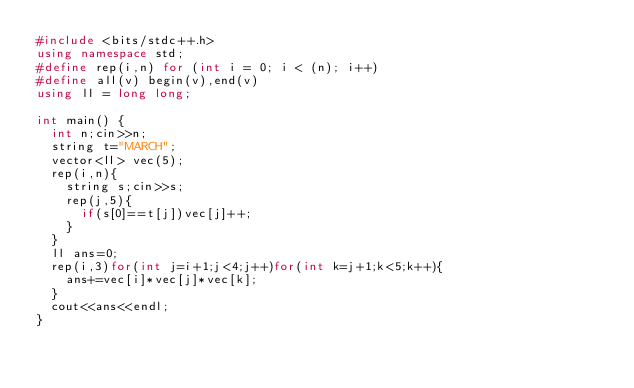Convert code to text. <code><loc_0><loc_0><loc_500><loc_500><_C++_>#include <bits/stdc++.h>
using namespace std;
#define rep(i,n) for (int i = 0; i < (n); i++) 
#define all(v) begin(v),end(v)
using ll = long long;

int main() {
  int n;cin>>n;
  string t="MARCH";
  vector<ll> vec(5);
  rep(i,n){
    string s;cin>>s;
    rep(j,5){
      if(s[0]==t[j])vec[j]++;
    }
  }
  ll ans=0;
  rep(i,3)for(int j=i+1;j<4;j++)for(int k=j+1;k<5;k++){
    ans+=vec[i]*vec[j]*vec[k];
  }
  cout<<ans<<endl;
}</code> 